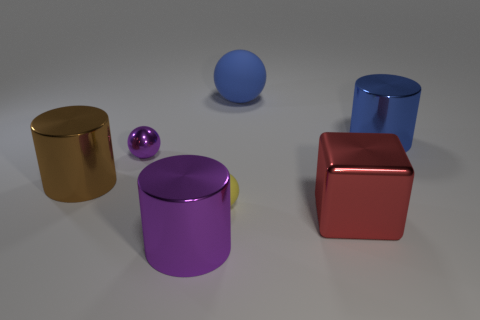What number of other large brown objects are the same shape as the brown shiny object?
Keep it short and to the point. 0. There is a rubber ball that is the same size as the purple shiny sphere; what is its color?
Your answer should be compact. Yellow. Are there an equal number of big purple things right of the big purple cylinder and tiny spheres that are in front of the large brown shiny thing?
Make the answer very short. No. Is there a brown metal cylinder of the same size as the cube?
Offer a very short reply. Yes. The yellow ball is what size?
Your answer should be compact. Small. Are there an equal number of large balls on the left side of the big brown cylinder and yellow shiny cubes?
Your answer should be compact. Yes. What number of other objects are the same color as the large cube?
Provide a short and direct response. 0. What color is the object that is both right of the large blue matte object and in front of the big blue metallic object?
Your answer should be very brief. Red. How big is the metal cylinder that is to the right of the big blue object left of the cylinder behind the purple shiny sphere?
Provide a short and direct response. Large. What number of objects are either rubber objects that are in front of the metallic ball or big things behind the red thing?
Your answer should be very brief. 4. 